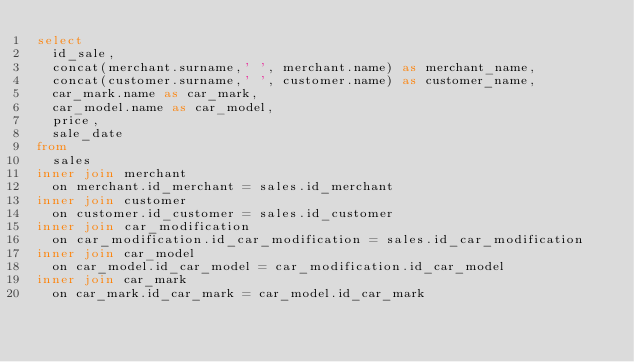<code> <loc_0><loc_0><loc_500><loc_500><_SQL_>select 
	id_sale,
	concat(merchant.surname,' ', merchant.name) as merchant_name,
	concat(customer.surname,' ', customer.name) as customer_name,
	car_mark.name as car_mark,
	car_model.name as car_model,
	price,
	sale_date
from 
	sales
inner join merchant 
	on merchant.id_merchant = sales.id_merchant
inner join customer 
	on customer.id_customer = sales.id_customer
inner join car_modification
	on car_modification.id_car_modification = sales.id_car_modification
inner join car_model 
	on car_model.id_car_model = car_modification.id_car_model
inner join car_mark 
	on car_mark.id_car_mark = car_model.id_car_mark</code> 